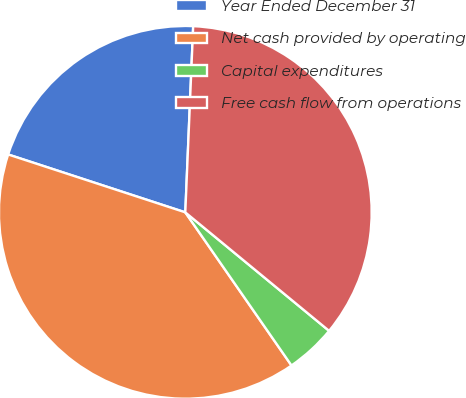<chart> <loc_0><loc_0><loc_500><loc_500><pie_chart><fcel>Year Ended December 31<fcel>Net cash provided by operating<fcel>Capital expenditures<fcel>Free cash flow from operations<nl><fcel>20.65%<fcel>39.68%<fcel>4.38%<fcel>35.3%<nl></chart> 